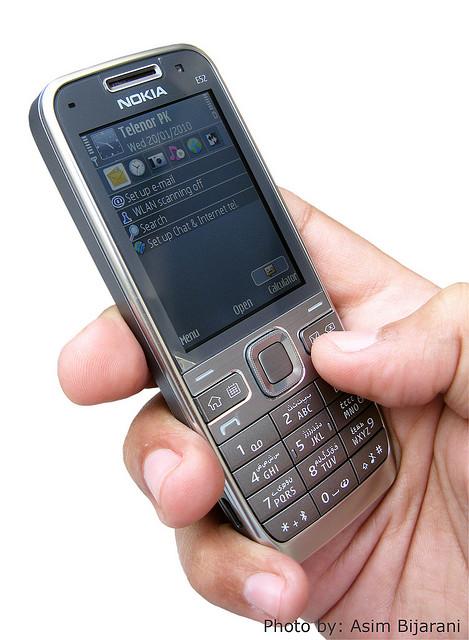Does this phone have a big screen?
Write a very short answer. No. Is this an iPhone?
Write a very short answer. No. Is this a flip phone?
Quick response, please. No. 